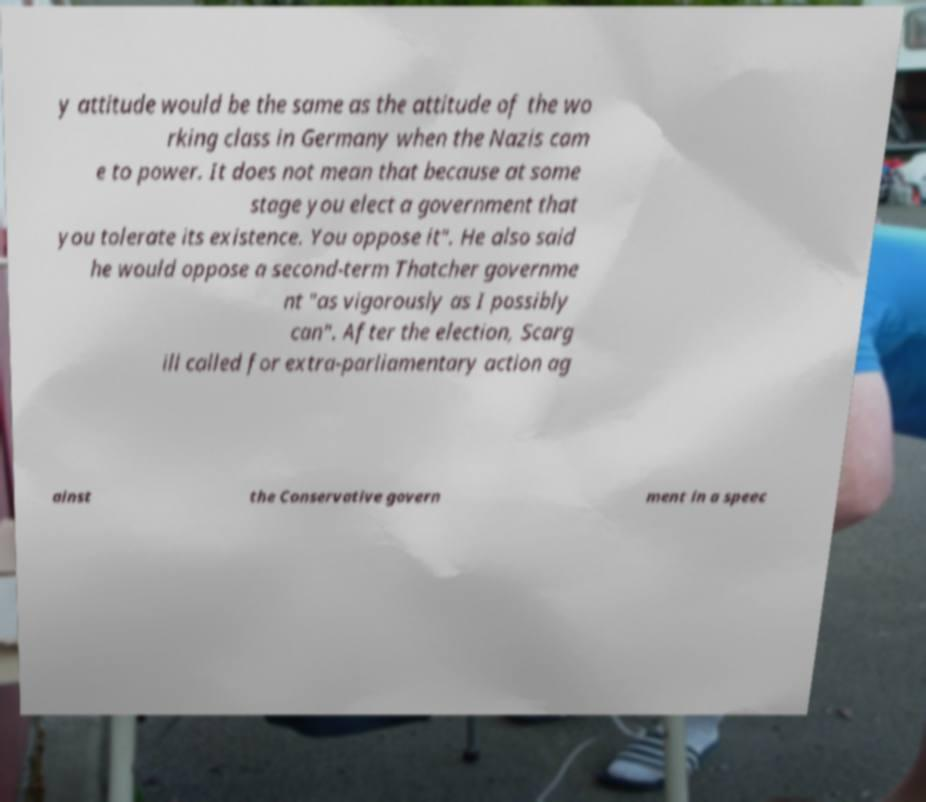Could you assist in decoding the text presented in this image and type it out clearly? y attitude would be the same as the attitude of the wo rking class in Germany when the Nazis cam e to power. It does not mean that because at some stage you elect a government that you tolerate its existence. You oppose it". He also said he would oppose a second-term Thatcher governme nt "as vigorously as I possibly can". After the election, Scarg ill called for extra-parliamentary action ag ainst the Conservative govern ment in a speec 